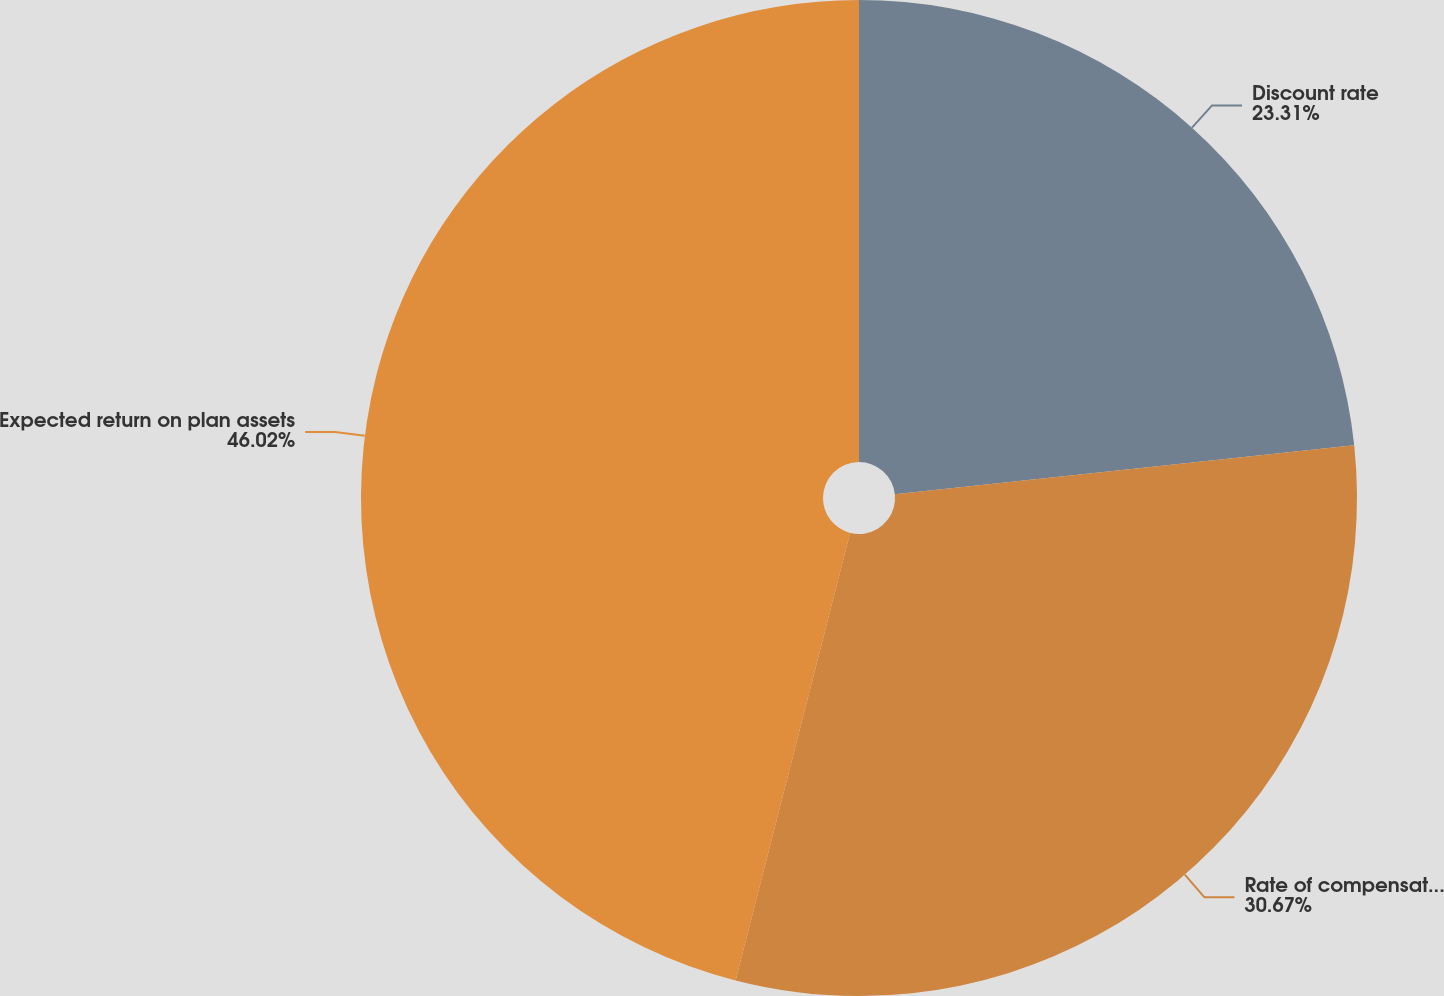<chart> <loc_0><loc_0><loc_500><loc_500><pie_chart><fcel>Discount rate<fcel>Rate of compensation increase<fcel>Expected return on plan assets<nl><fcel>23.31%<fcel>30.67%<fcel>46.01%<nl></chart> 